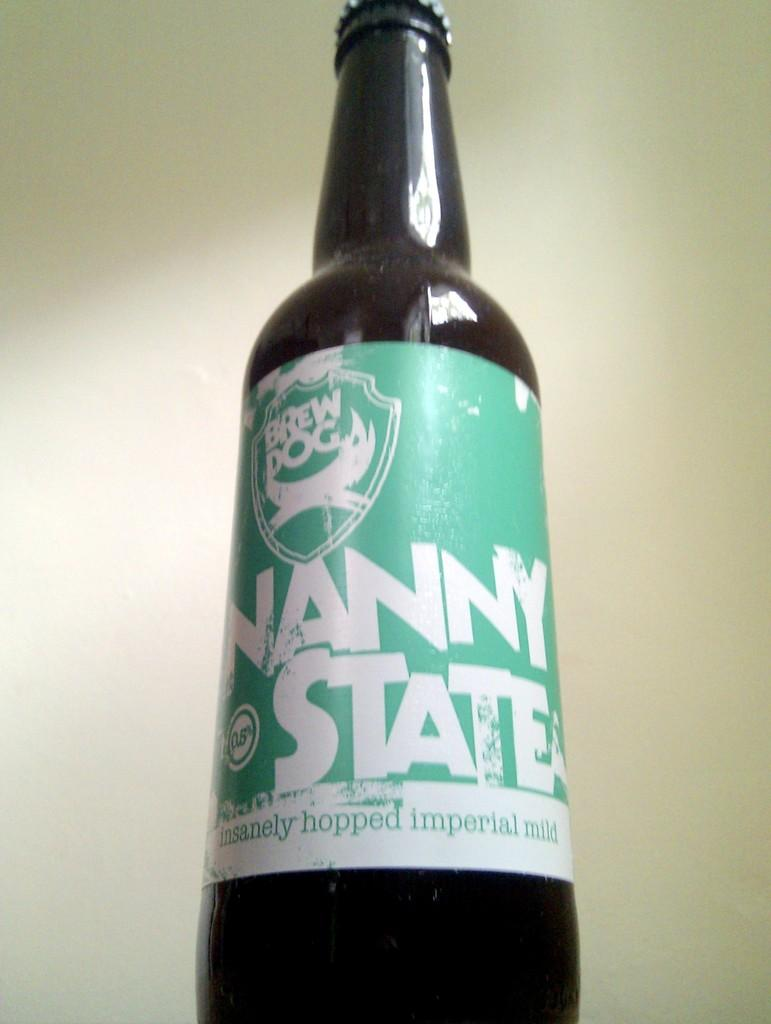<image>
Create a compact narrative representing the image presented. A green and white label says nanny state by Brew Dog. 